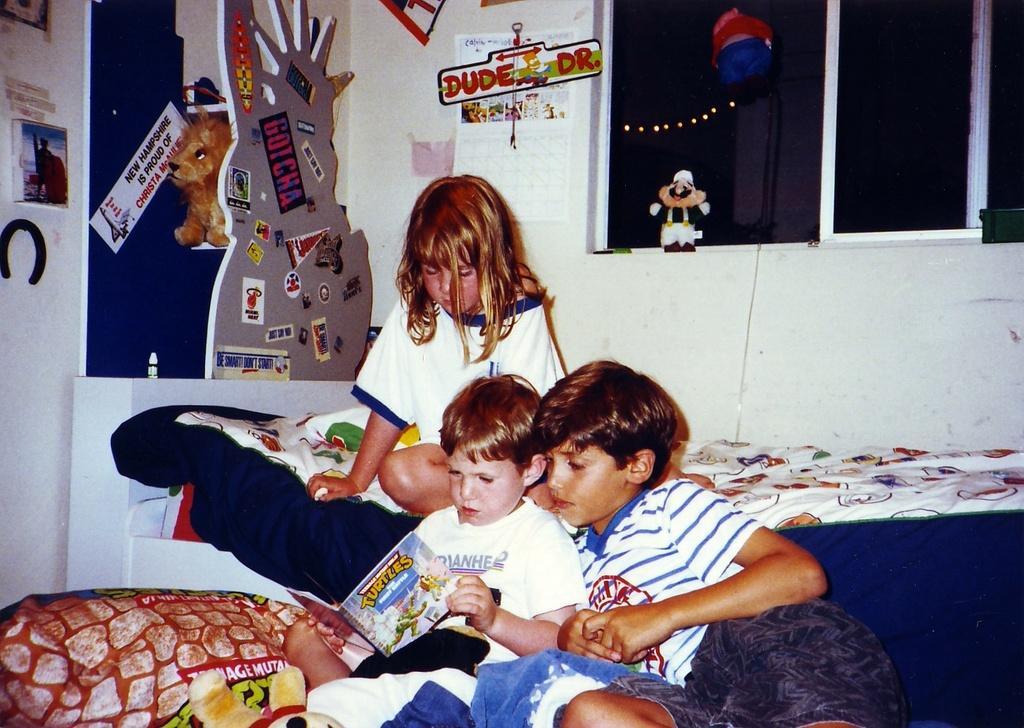How would you summarize this image in a sentence or two? As we can see in the image there is a wall, poster, windows, toy and few people sitting on beds. 